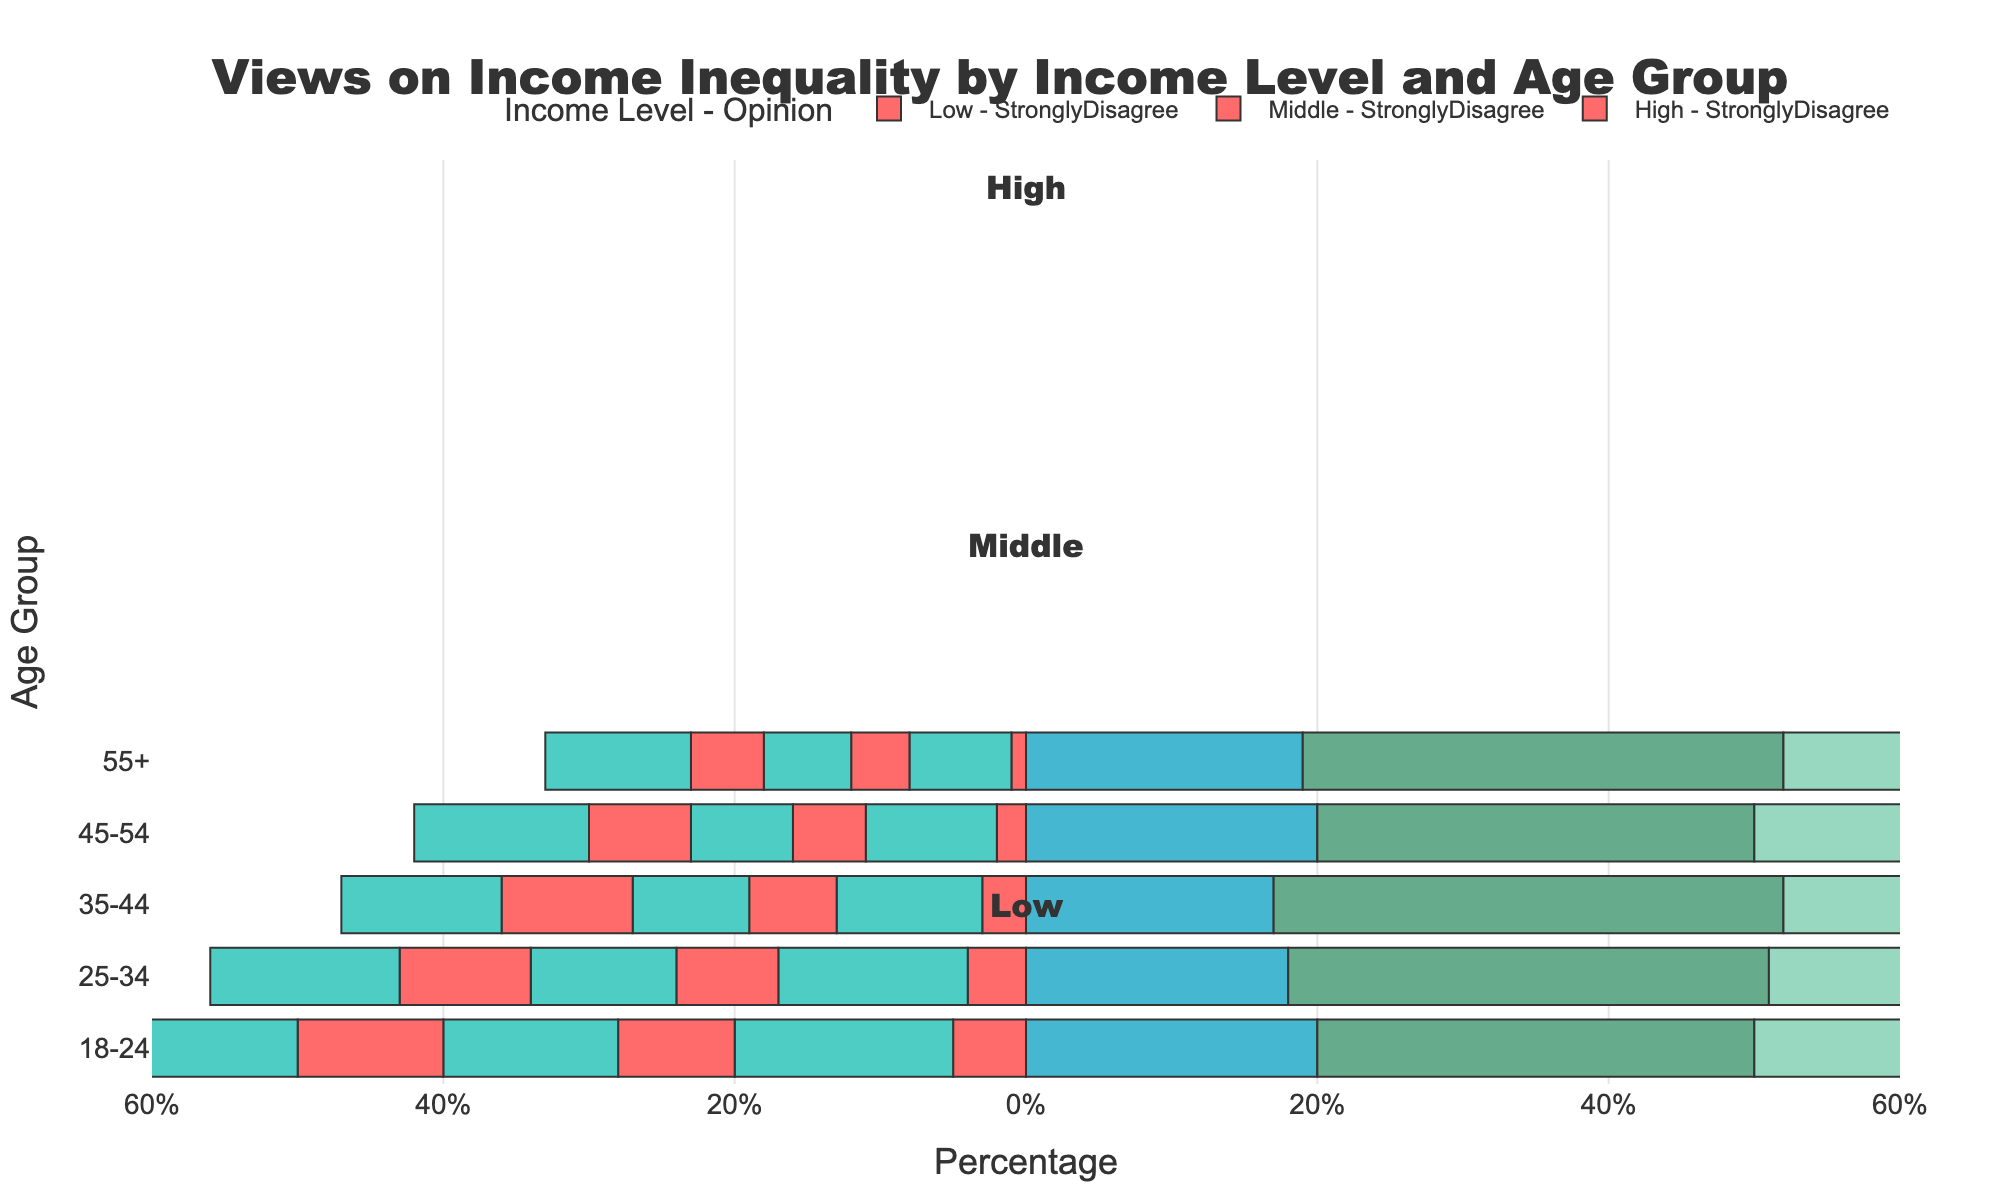What age group within the low-income level has the highest percentage of people who strongly agree with views on income inequality? To determine which age group within the low-income level has the highest percentage of people who strongly agree with views on income inequality, look at the Strongly Agree category bar lengths for low-income groups. The 55+ group has the longest bar, indicating the highest percentage.
Answer: 55+ Compare the middle-income and high-income levels for the age group 35-44 in terms of the percentage of people who agree with views on income inequality. Which has a higher percentage? To compare the middle and high-income levels for the age group 35-44 in terms of agreement with views on income inequality, look at the Agree category bars for both income levels. Middle-income has a 34% bar, while high-income has a 30% bar. Hence, middle-income has a higher percentage.
Answer: Middle-income Which age group among all income levels has the lowest percentage of people who strongly disagree with views on income inequality? To find the age group with the lowest percentage of strong disagreement, look for the shortest bar in the Strongly Disagree category across all income levels. The low-income 55+ group has the shortest bar, indicating a 1% strong disagreement.
Answer: Low-income 55+ Across all age groups, which income level shows the highest percentage of neutrality toward views on income inequality? Look for the longest Neutral category bar across all income levels and age groups. In the high-income 18-24 group, the Neutral bar is 25%, the highest among all categories.
Answer: High-income Calculate the total percentage of people who agree within the age group 45-54 irrespective of their income levels. To calculate the total percentage of agreement within the age group 45-54 irrespective of income levels, sum up the Agree percentages for each income level in this group. Low-income: 30%, Middle-income: 28%, High-income: 25%, summing up to 30 + 28 + 25 = 83%.
Answer: 83% Compare the 25-34 age group for low and middle-income levels in terms of neutral views on income inequality. Which income level has a higher percentage? Look at the Neutral category bars for the age group 25-34 for both low and middle-income levels. The low-income group has 18% while the middle-income group has 20%, indicating the middle-income level has a higher percentage.
Answer: Middle-income Which income level and age group combination shows the highest percentage of agreement or strong agreement with views on income inequality? Identify the combination with the longest bars in either Agree or Strongly Agree categories across all income level and age group combinations. The low-income 55+ group has the highest percentage with Strongly Agree at 40%.
Answer: Low-income 55+ Calculate the combined percentage of disagreement (both strongly disagree and disagree) for high-income groups aged 18-24. To calculate the combined percentage of disagreement in the high-income 18-24 group, add the Strongly Disagree and Disagree percentages: 10% + 15% = 25%.
Answer: 25% For the age group 18-24, which income level shows the highest percentage of people who disagree with views on income inequality? For the age group 18-24, compare the Disagree category bars for all income levels. The high-income level shows the highest percentage at 15%.
Answer: High-income Among middle-income groups, which age group has the highest total percentage for neutral views and disagreement (both strongly disagree and disagree) combined? Calculate the combined percentage for Strongly Disagree, Disagree, and Neutral for each age group within middle-income. The 18-24 group has a combined percentage of 8% (strongly disagree) + 12% (disagree) + 22% (neutral) = 42%, the highest among all age groups in middle-income.
Answer: 18-24 